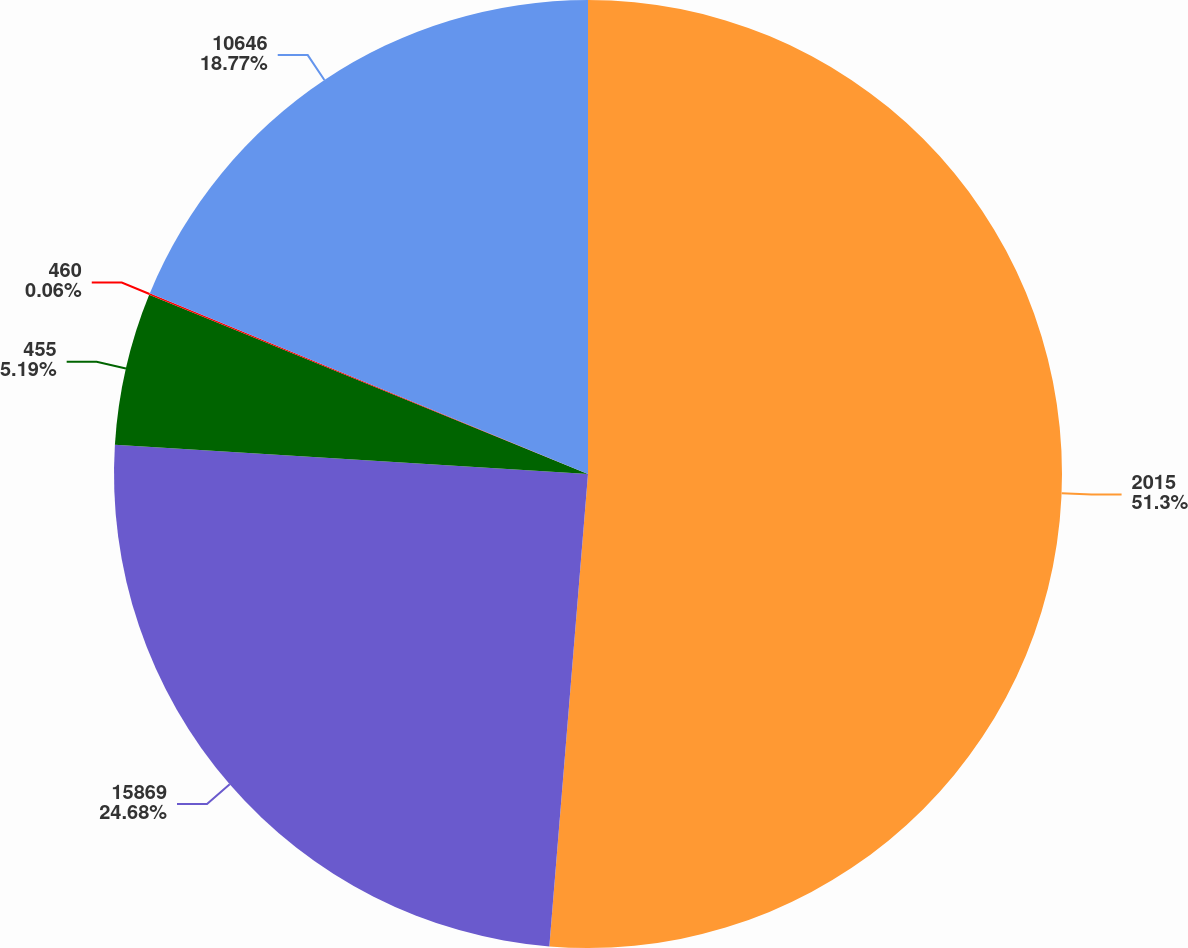Convert chart to OTSL. <chart><loc_0><loc_0><loc_500><loc_500><pie_chart><fcel>2015<fcel>15869<fcel>455<fcel>460<fcel>10646<nl><fcel>51.3%<fcel>24.68%<fcel>5.19%<fcel>0.06%<fcel>18.77%<nl></chart> 